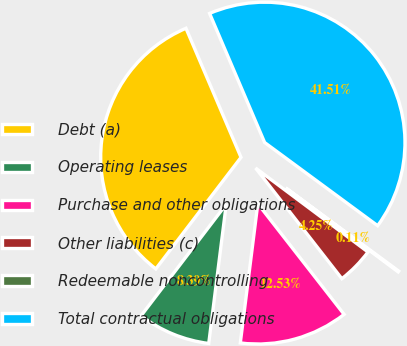<chart> <loc_0><loc_0><loc_500><loc_500><pie_chart><fcel>Debt (a)<fcel>Operating leases<fcel>Purchase and other obligations<fcel>Other liabilities (c)<fcel>Redeemable noncontrolling<fcel>Total contractual obligations<nl><fcel>33.2%<fcel>8.39%<fcel>12.53%<fcel>4.25%<fcel>0.11%<fcel>41.51%<nl></chart> 